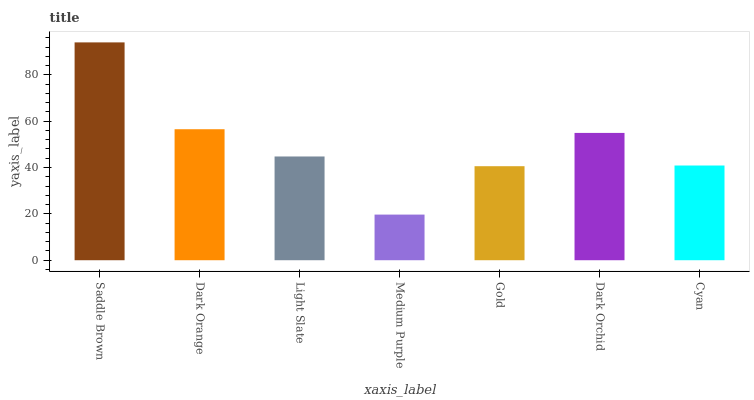Is Dark Orange the minimum?
Answer yes or no. No. Is Dark Orange the maximum?
Answer yes or no. No. Is Saddle Brown greater than Dark Orange?
Answer yes or no. Yes. Is Dark Orange less than Saddle Brown?
Answer yes or no. Yes. Is Dark Orange greater than Saddle Brown?
Answer yes or no. No. Is Saddle Brown less than Dark Orange?
Answer yes or no. No. Is Light Slate the high median?
Answer yes or no. Yes. Is Light Slate the low median?
Answer yes or no. Yes. Is Cyan the high median?
Answer yes or no. No. Is Medium Purple the low median?
Answer yes or no. No. 